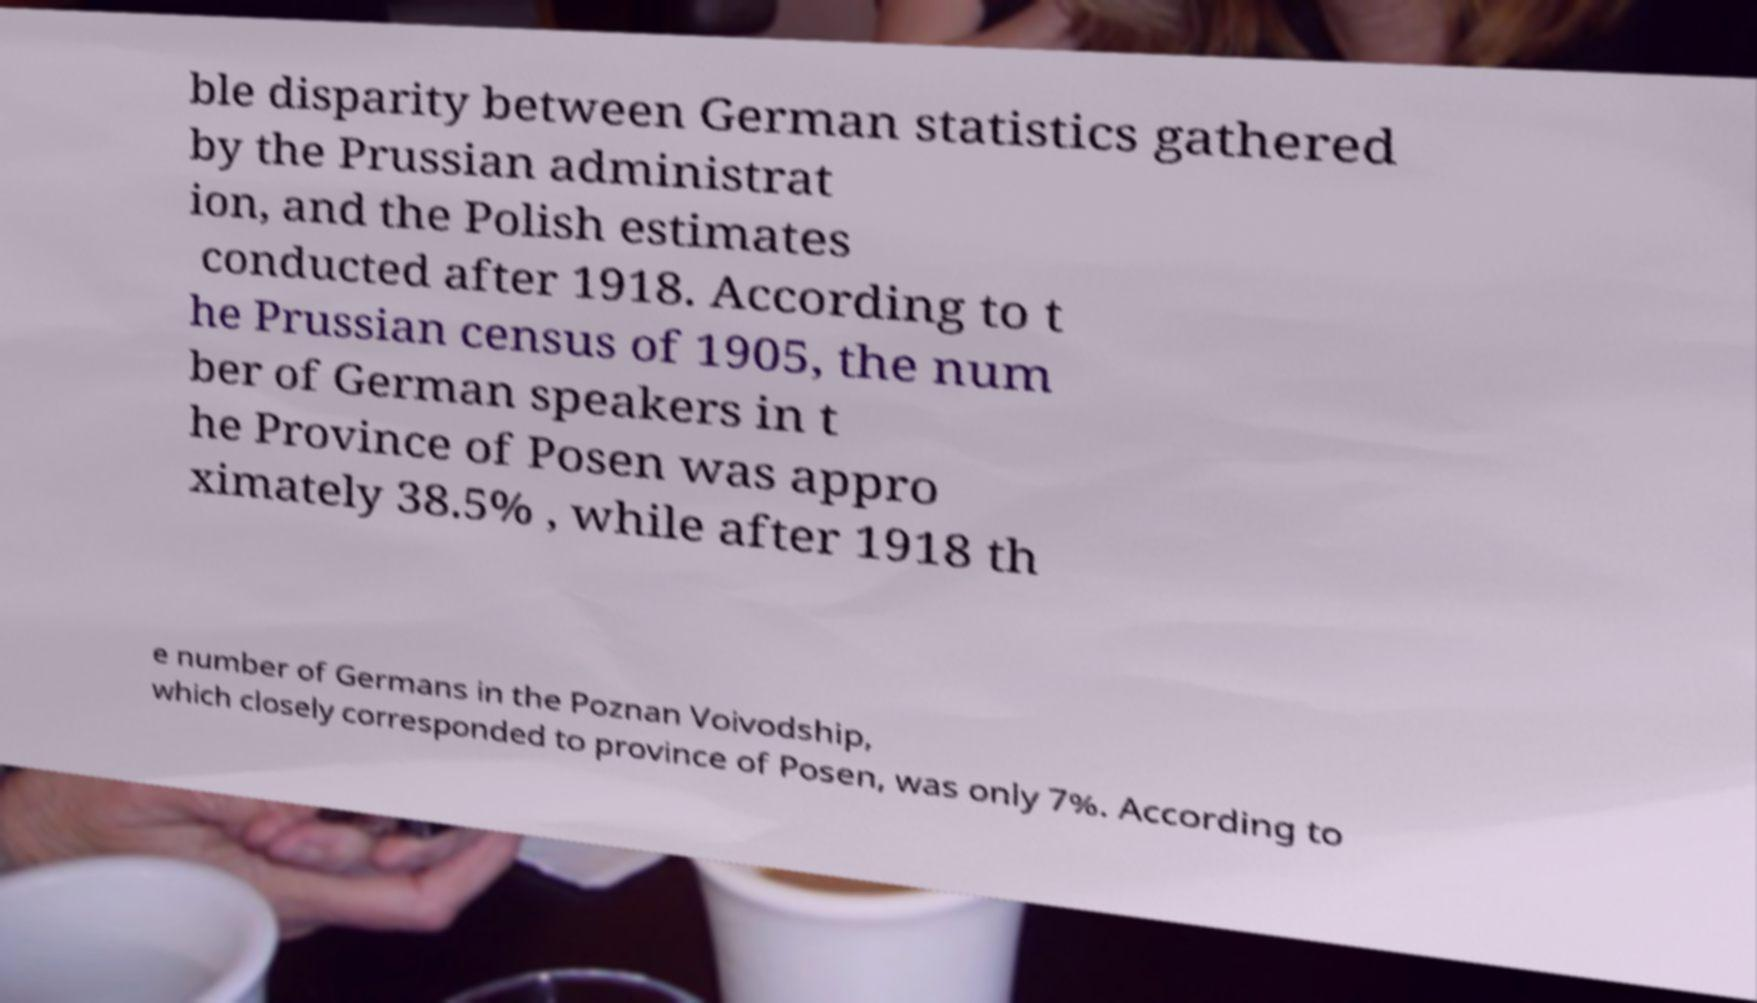Can you read and provide the text displayed in the image?This photo seems to have some interesting text. Can you extract and type it out for me? ble disparity between German statistics gathered by the Prussian administrat ion, and the Polish estimates conducted after 1918. According to t he Prussian census of 1905, the num ber of German speakers in t he Province of Posen was appro ximately 38.5% , while after 1918 th e number of Germans in the Poznan Voivodship, which closely corresponded to province of Posen, was only 7%. According to 